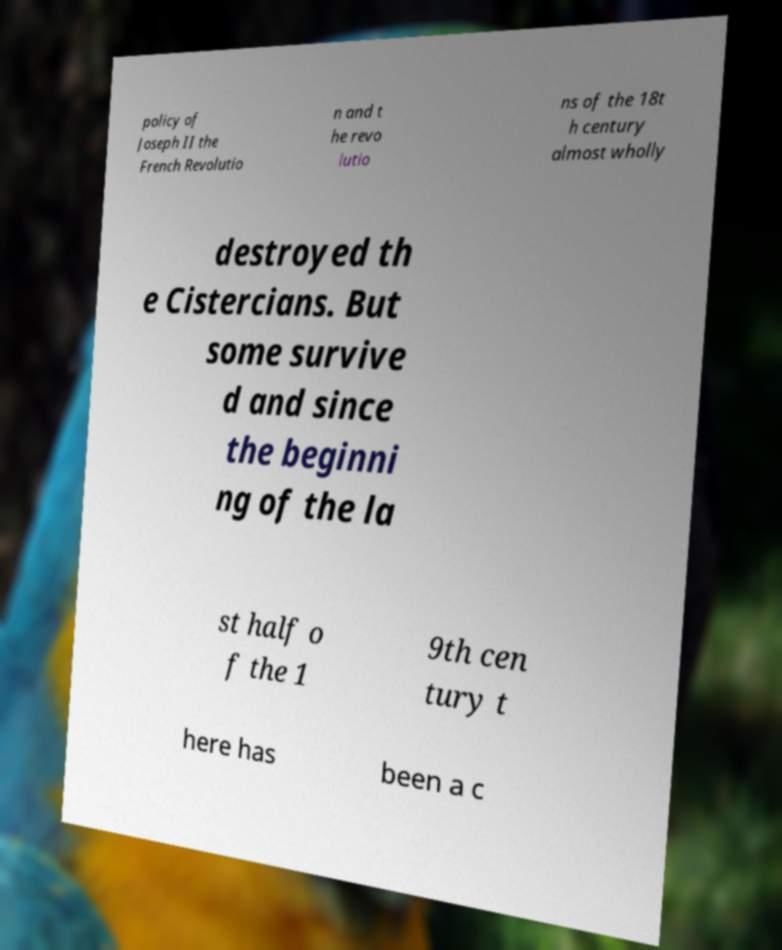Can you accurately transcribe the text from the provided image for me? policy of Joseph II the French Revolutio n and t he revo lutio ns of the 18t h century almost wholly destroyed th e Cistercians. But some survive d and since the beginni ng of the la st half o f the 1 9th cen tury t here has been a c 